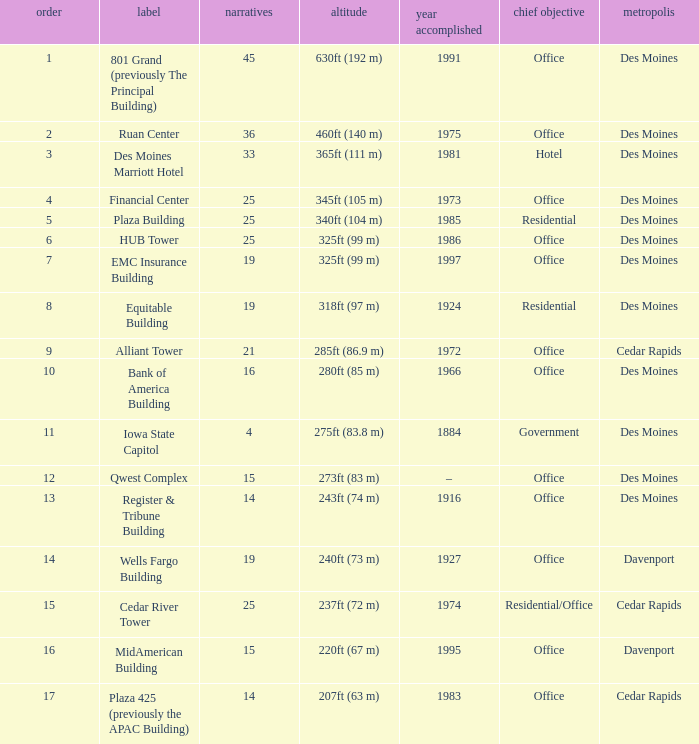What is the height of the EMC Insurance Building in Des Moines? 325ft (99 m). 